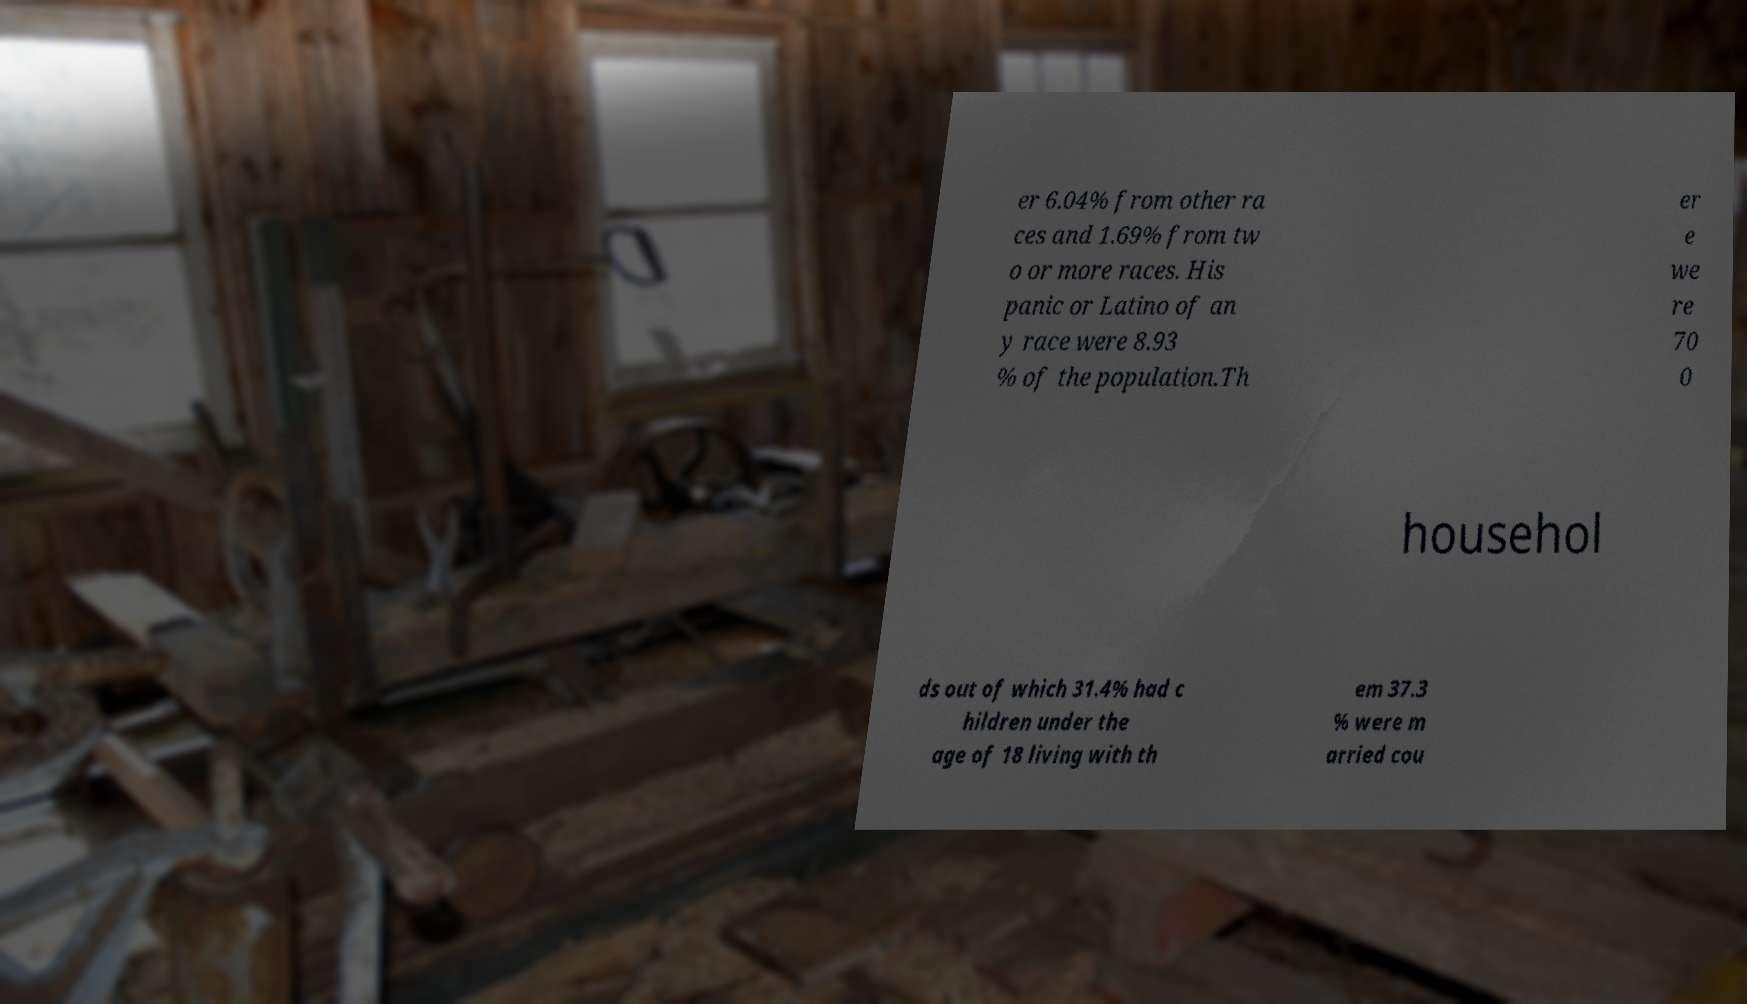Can you accurately transcribe the text from the provided image for me? er 6.04% from other ra ces and 1.69% from tw o or more races. His panic or Latino of an y race were 8.93 % of the population.Th er e we re 70 0 househol ds out of which 31.4% had c hildren under the age of 18 living with th em 37.3 % were m arried cou 